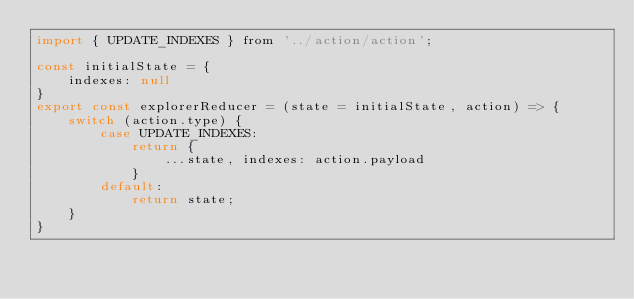Convert code to text. <code><loc_0><loc_0><loc_500><loc_500><_JavaScript_>import { UPDATE_INDEXES } from '../action/action';

const initialState = {
    indexes: null
}
export const explorerReducer = (state = initialState, action) => {
    switch (action.type) {
        case UPDATE_INDEXES:
            return {
                ...state, indexes: action.payload
            }
        default:
            return state;
    }
}</code> 